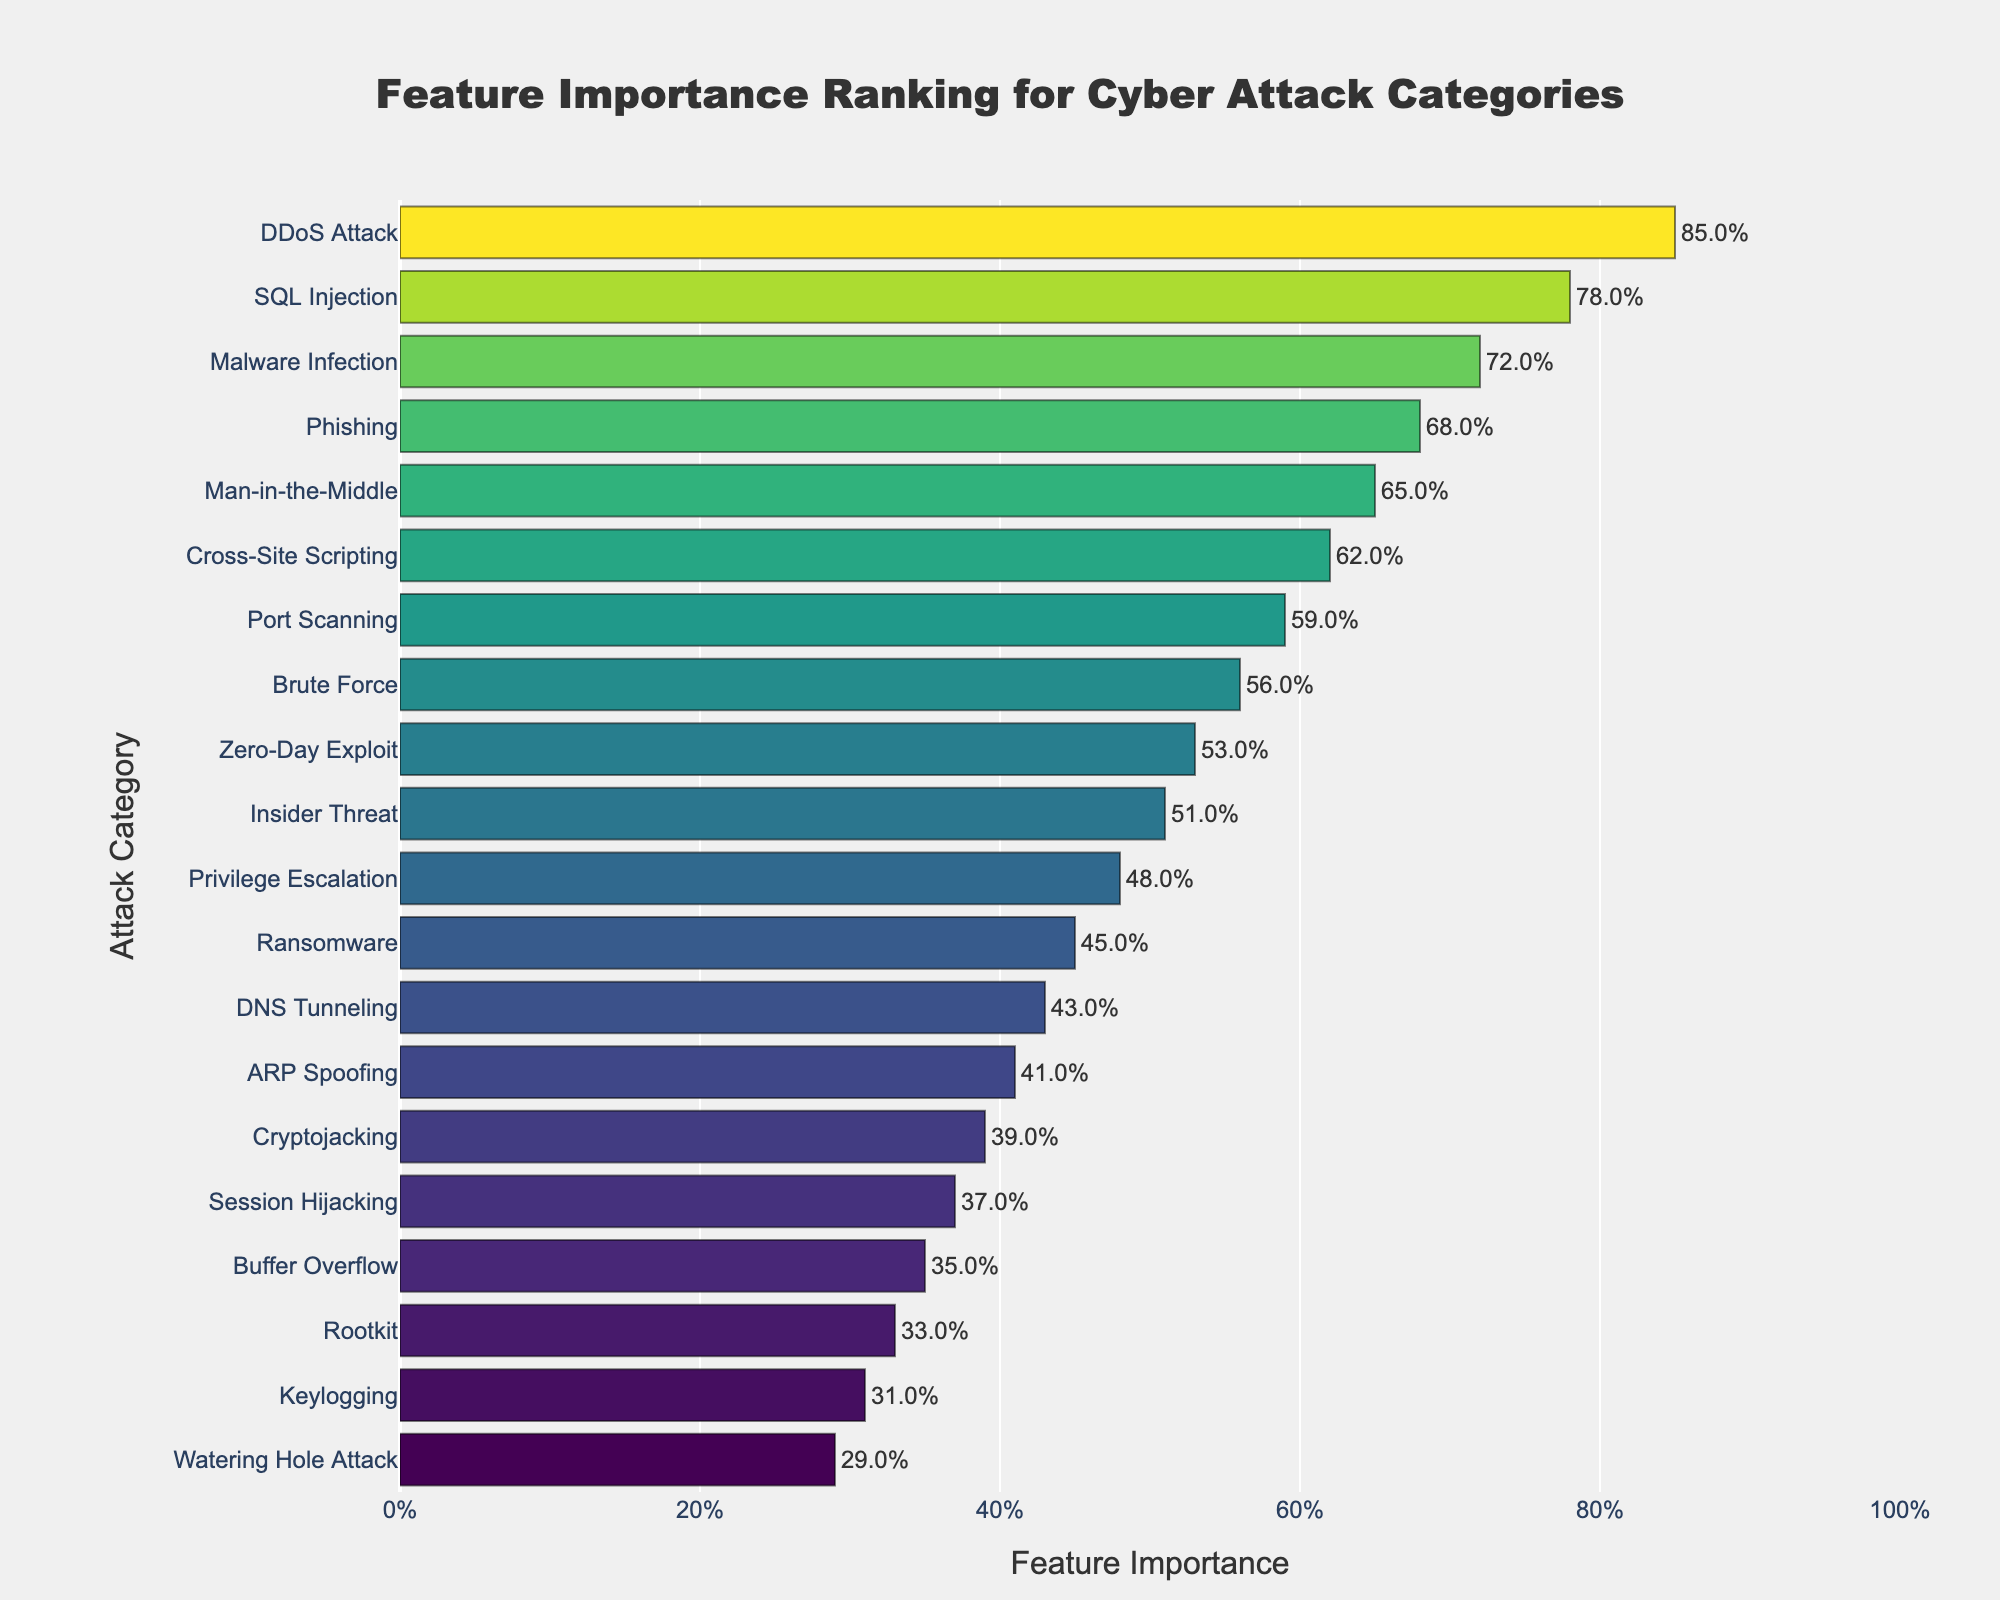What category has the highest feature importance? By observing the bar chart, the highest feature importance correspond to the category with the longest bar. The DDoS Attack category has the longest bar on the chart.
Answer: DDoS Attack What is the feature importance difference between the DDoS Attack and the Cryptojacking categories? From the figure, the feature importance for DDoS Attack is 0.85, and for Cryptojacking, it is 0.39. The difference is 0.85 - 0.39.
Answer: 0.46 Which category has the lowest feature importance, and what is its value? By looking at the shortest bar on the chart, the category with the lowest feature importance is Watering Hole Attack. The value is at the end of the bar, which is 0.29.
Answer: Watering Hole Attack, 0.29 How many categories have a feature importance greater than 0.6? Finding the bars that exceed the 0.6 mark, there are six categories that meet this criterion.
Answer: 6 Compare the feature importances of SQL Injection and Brute Force. Which one is higher, and by how much? The feature importance for SQL Injection is 0.78, and for Brute Force, it is 0.56. SQL Injection is higher. The difference is 0.78 - 0.56.
Answer: SQL Injection by 0.22 What's the sum of the feature importances for Phishing, Malware Infection, and Zero-Day Exploit categories? Adding the feature importances from the visual data: Phishing (0.68), Malware Infection (0.72), and Zero-Day Exploit (0.53), we get 0.68 + 0.72 + 0.53.
Answer: 1.93 What is the average feature importance of the top five attack categories? The top five categories by feature importance are DDoS Attack (0.85), SQL Injection (0.78), Malware Infection (0.72), Phishing (0.68), and Man-in-the-Middle (0.65). The average is (0.85 + 0.78 + 0.72 + 0.68 + 0.65) / 5.
Answer: 0.736 How does the feature importance of Privilege Escalation compare to that of ARP Spoofing? The feature importance for Privilege Escalation is 0.48, and for ARP Spoofing, it is 0.41. Privilege Escalation is higher.
Answer: Privilege Escalation What is the median feature importance value for the listed categories? To find the median, first, sort all feature importance values. The median value is the middle number in this sorted list, which in this case is the 10th value if evenly distributed. By looking at the sorted visual data, the median feature importance is 0.51.
Answer: 0.51 